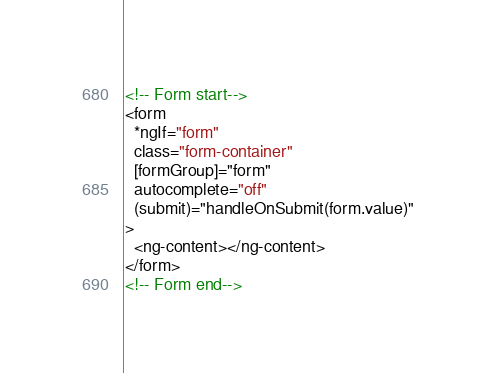<code> <loc_0><loc_0><loc_500><loc_500><_HTML_><!-- Form start-->
<form
  *ngIf="form"
  class="form-container"
  [formGroup]="form"
  autocomplete="off"
  (submit)="handleOnSubmit(form.value)"
>
  <ng-content></ng-content>
</form>
<!-- Form end-->
</code> 